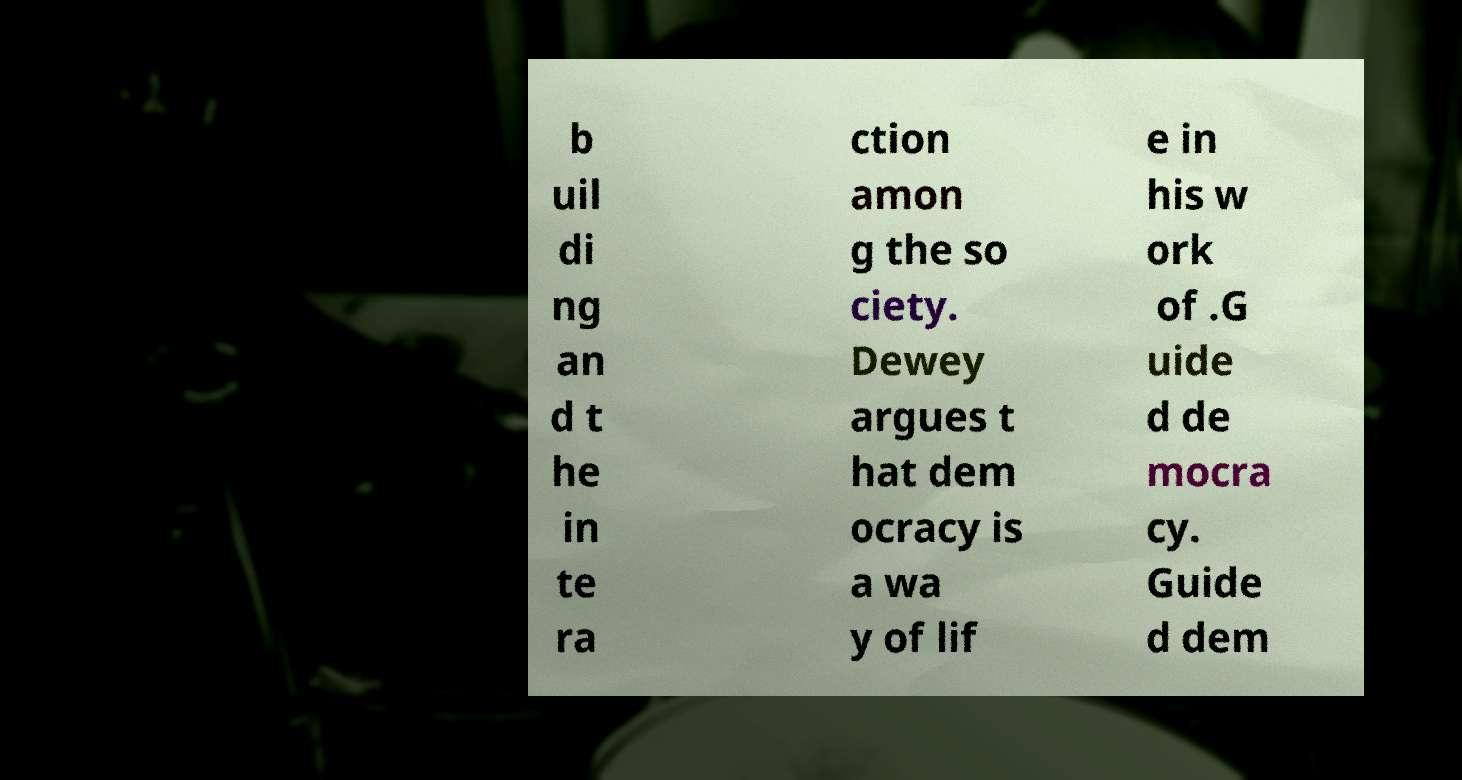Can you read and provide the text displayed in the image?This photo seems to have some interesting text. Can you extract and type it out for me? b uil di ng an d t he in te ra ction amon g the so ciety. Dewey argues t hat dem ocracy is a wa y of lif e in his w ork of .G uide d de mocra cy. Guide d dem 